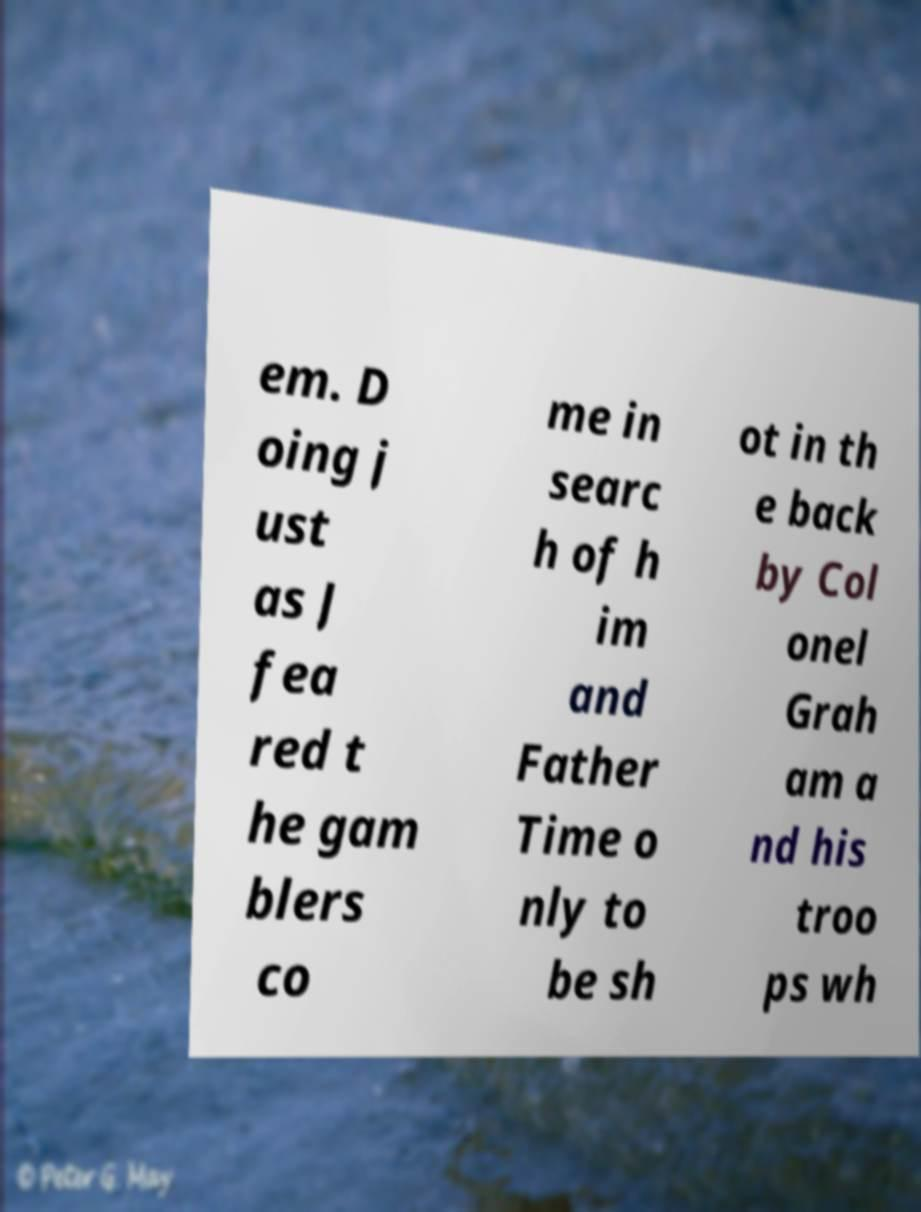Please read and relay the text visible in this image. What does it say? em. D oing j ust as J fea red t he gam blers co me in searc h of h im and Father Time o nly to be sh ot in th e back by Col onel Grah am a nd his troo ps wh 